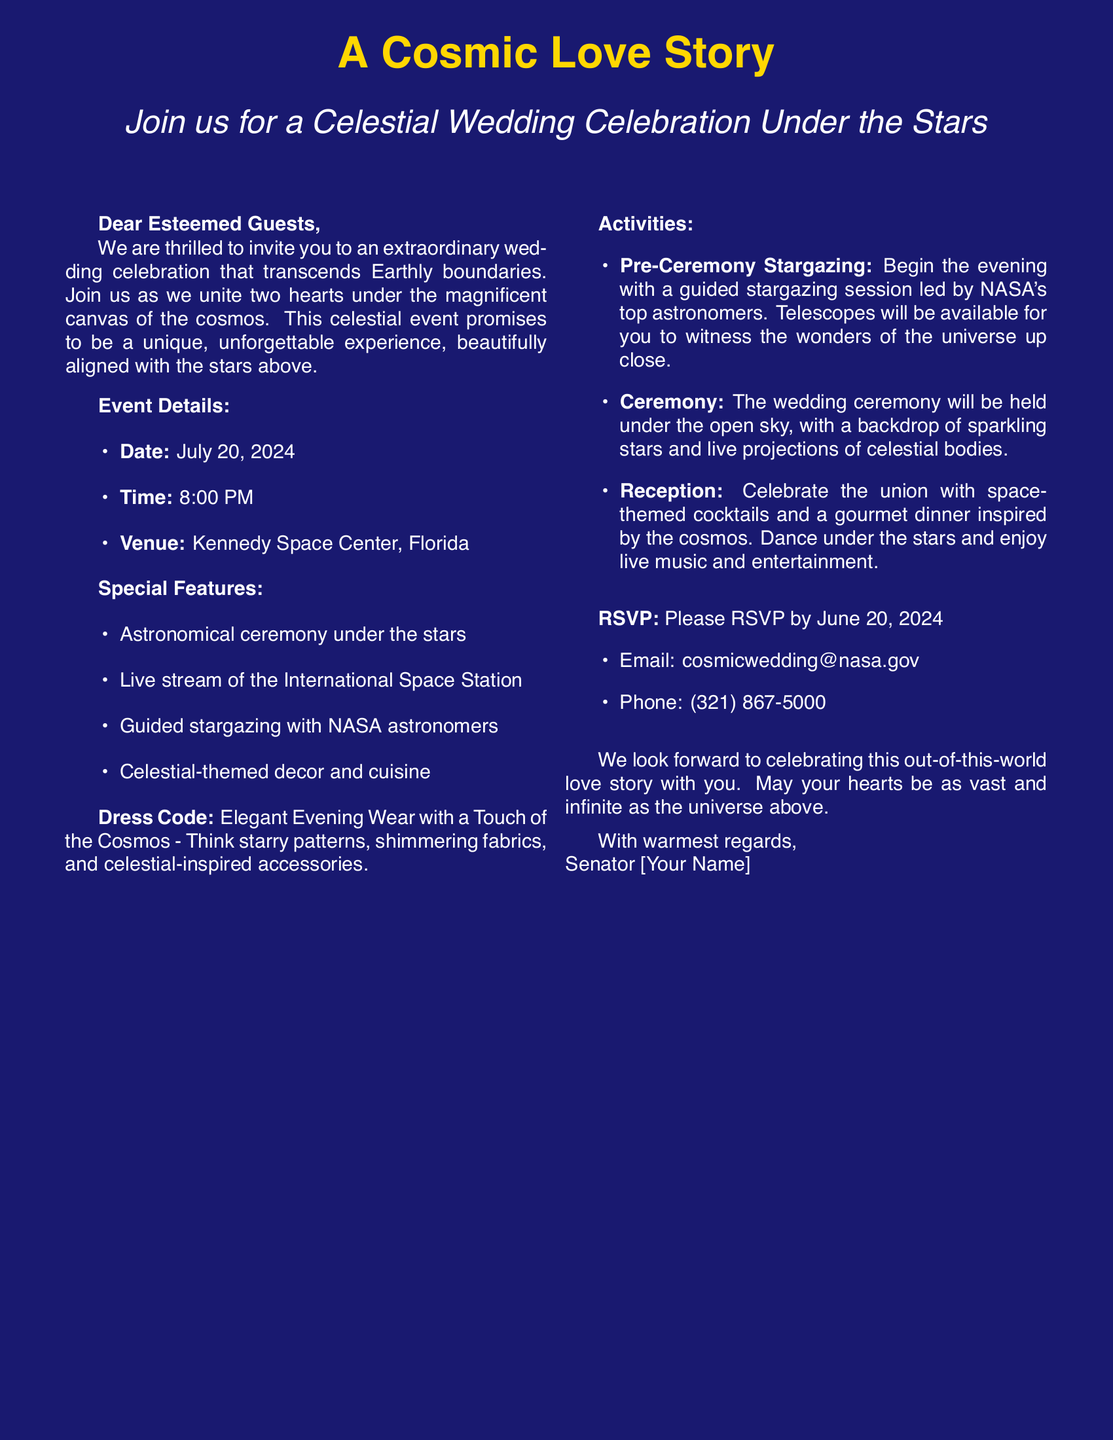What is the date of the wedding? The date of the wedding is explicitly mentioned in the event details.
Answer: July 20, 2024 What time does the wedding ceremony start? The starting time of the ceremony is provided in the event details section of the invitation.
Answer: 8:00 PM Where is the wedding venue located? The venue is specified in the event details part of the document.
Answer: Kennedy Space Center, Florida What is the dress code for the event? The dress code is mentioned in the document and provides insight into the expected attire for guests.
Answer: Elegant Evening Wear with a Touch of the Cosmos What special feature includes NASA astronomers? The feature involving NASA astronomers is mentioned under the "Special Features" section of the invitation.
Answer: Guided stargazing What should guests prepare for the pre-ceremony? The invitation details what guests can participate in before the ceremony, requiring them to engage in a specific activity.
Answer: Guided stargazing session What type of cuisine will be served at the reception? The reception's food theme is specified, indicating a celestial inspiration for the meal experience.
Answer: Gourmet dinner inspired by the cosmos What is the RSVP deadline? The deadline for RSVPs is clearly stated in the document for the convenience of the guests.
Answer: June 20, 2024 What is the format of the wedding ceremony? The format of the wedding ceremony is indicated, providing a glimpse into the atmosphere and arrangement of the event.
Answer: Under the open sky 